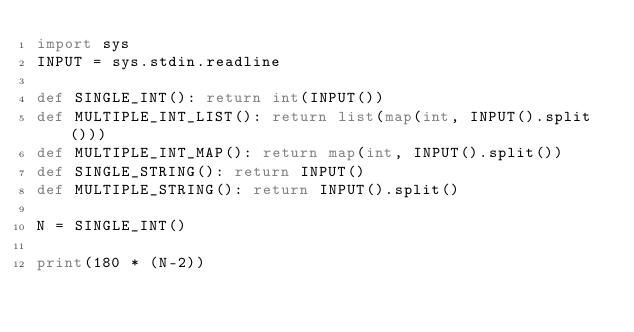<code> <loc_0><loc_0><loc_500><loc_500><_Python_>import sys
INPUT = sys.stdin.readline

def SINGLE_INT(): return int(INPUT())
def MULTIPLE_INT_LIST(): return list(map(int, INPUT().split()))
def MULTIPLE_INT_MAP(): return map(int, INPUT().split())
def SINGLE_STRING(): return INPUT()
def MULTIPLE_STRING(): return INPUT().split()

N = SINGLE_INT()

print(180 * (N-2))</code> 